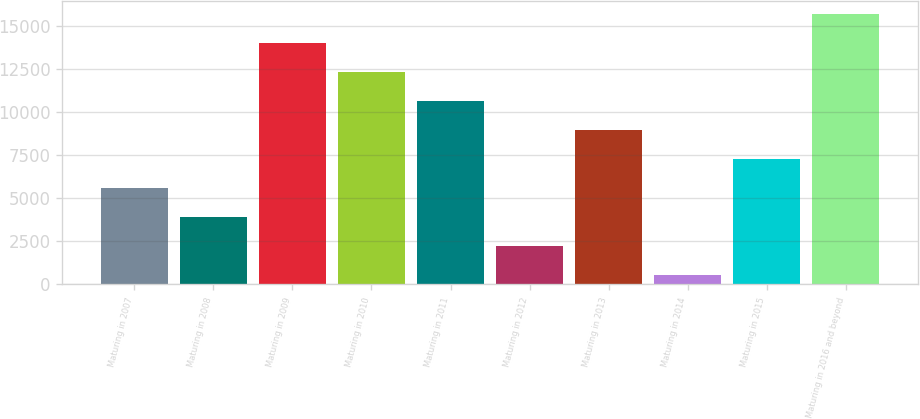Convert chart to OTSL. <chart><loc_0><loc_0><loc_500><loc_500><bar_chart><fcel>Maturing in 2007<fcel>Maturing in 2008<fcel>Maturing in 2009<fcel>Maturing in 2010<fcel>Maturing in 2011<fcel>Maturing in 2012<fcel>Maturing in 2013<fcel>Maturing in 2014<fcel>Maturing in 2015<fcel>Maturing in 2016 and beyond<nl><fcel>5578.2<fcel>3893.8<fcel>14000.2<fcel>12315.8<fcel>10631.4<fcel>2209.4<fcel>8947<fcel>525<fcel>7262.6<fcel>15684.6<nl></chart> 